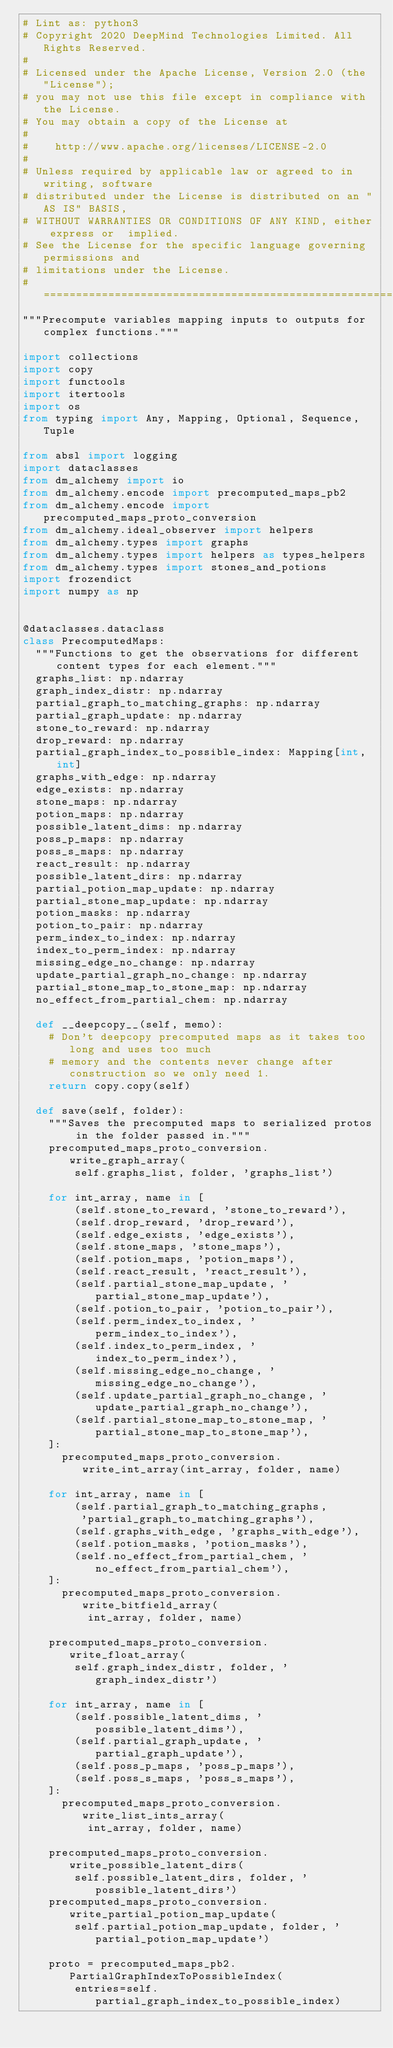<code> <loc_0><loc_0><loc_500><loc_500><_Python_># Lint as: python3
# Copyright 2020 DeepMind Technologies Limited. All Rights Reserved.
#
# Licensed under the Apache License, Version 2.0 (the "License");
# you may not use this file except in compliance with the License.
# You may obtain a copy of the License at
#
#    http://www.apache.org/licenses/LICENSE-2.0
#
# Unless required by applicable law or agreed to in writing, software
# distributed under the License is distributed on an "AS IS" BASIS,
# WITHOUT WARRANTIES OR CONDITIONS OF ANY KIND, either express or  implied.
# See the License for the specific language governing permissions and
# limitations under the License.
# ============================================================================
"""Precompute variables mapping inputs to outputs for complex functions."""

import collections
import copy
import functools
import itertools
import os
from typing import Any, Mapping, Optional, Sequence, Tuple

from absl import logging
import dataclasses
from dm_alchemy import io
from dm_alchemy.encode import precomputed_maps_pb2
from dm_alchemy.encode import precomputed_maps_proto_conversion
from dm_alchemy.ideal_observer import helpers
from dm_alchemy.types import graphs
from dm_alchemy.types import helpers as types_helpers
from dm_alchemy.types import stones_and_potions
import frozendict
import numpy as np


@dataclasses.dataclass
class PrecomputedMaps:
  """Functions to get the observations for different content types for each element."""
  graphs_list: np.ndarray
  graph_index_distr: np.ndarray
  partial_graph_to_matching_graphs: np.ndarray
  partial_graph_update: np.ndarray
  stone_to_reward: np.ndarray
  drop_reward: np.ndarray
  partial_graph_index_to_possible_index: Mapping[int, int]
  graphs_with_edge: np.ndarray
  edge_exists: np.ndarray
  stone_maps: np.ndarray
  potion_maps: np.ndarray
  possible_latent_dims: np.ndarray
  poss_p_maps: np.ndarray
  poss_s_maps: np.ndarray
  react_result: np.ndarray
  possible_latent_dirs: np.ndarray
  partial_potion_map_update: np.ndarray
  partial_stone_map_update: np.ndarray
  potion_masks: np.ndarray
  potion_to_pair: np.ndarray
  perm_index_to_index: np.ndarray
  index_to_perm_index: np.ndarray
  missing_edge_no_change: np.ndarray
  update_partial_graph_no_change: np.ndarray
  partial_stone_map_to_stone_map: np.ndarray
  no_effect_from_partial_chem: np.ndarray

  def __deepcopy__(self, memo):
    # Don't deepcopy precomputed maps as it takes too long and uses too much
    # memory and the contents never change after construction so we only need 1.
    return copy.copy(self)

  def save(self, folder):
    """Saves the precomputed maps to serialized protos in the folder passed in."""
    precomputed_maps_proto_conversion.write_graph_array(
        self.graphs_list, folder, 'graphs_list')

    for int_array, name in [
        (self.stone_to_reward, 'stone_to_reward'),
        (self.drop_reward, 'drop_reward'),
        (self.edge_exists, 'edge_exists'),
        (self.stone_maps, 'stone_maps'),
        (self.potion_maps, 'potion_maps'),
        (self.react_result, 'react_result'),
        (self.partial_stone_map_update, 'partial_stone_map_update'),
        (self.potion_to_pair, 'potion_to_pair'),
        (self.perm_index_to_index, 'perm_index_to_index'),
        (self.index_to_perm_index, 'index_to_perm_index'),
        (self.missing_edge_no_change, 'missing_edge_no_change'),
        (self.update_partial_graph_no_change, 'update_partial_graph_no_change'),
        (self.partial_stone_map_to_stone_map, 'partial_stone_map_to_stone_map'),
    ]:
      precomputed_maps_proto_conversion.write_int_array(int_array, folder, name)

    for int_array, name in [
        (self.partial_graph_to_matching_graphs,
         'partial_graph_to_matching_graphs'),
        (self.graphs_with_edge, 'graphs_with_edge'),
        (self.potion_masks, 'potion_masks'),
        (self.no_effect_from_partial_chem, 'no_effect_from_partial_chem'),
    ]:
      precomputed_maps_proto_conversion.write_bitfield_array(
          int_array, folder, name)

    precomputed_maps_proto_conversion.write_float_array(
        self.graph_index_distr, folder, 'graph_index_distr')

    for int_array, name in [
        (self.possible_latent_dims, 'possible_latent_dims'),
        (self.partial_graph_update, 'partial_graph_update'),
        (self.poss_p_maps, 'poss_p_maps'),
        (self.poss_s_maps, 'poss_s_maps'),
    ]:
      precomputed_maps_proto_conversion.write_list_ints_array(
          int_array, folder, name)

    precomputed_maps_proto_conversion.write_possible_latent_dirs(
        self.possible_latent_dirs, folder, 'possible_latent_dirs')
    precomputed_maps_proto_conversion.write_partial_potion_map_update(
        self.partial_potion_map_update, folder, 'partial_potion_map_update')

    proto = precomputed_maps_pb2.PartialGraphIndexToPossibleIndex(
        entries=self.partial_graph_index_to_possible_index)</code> 